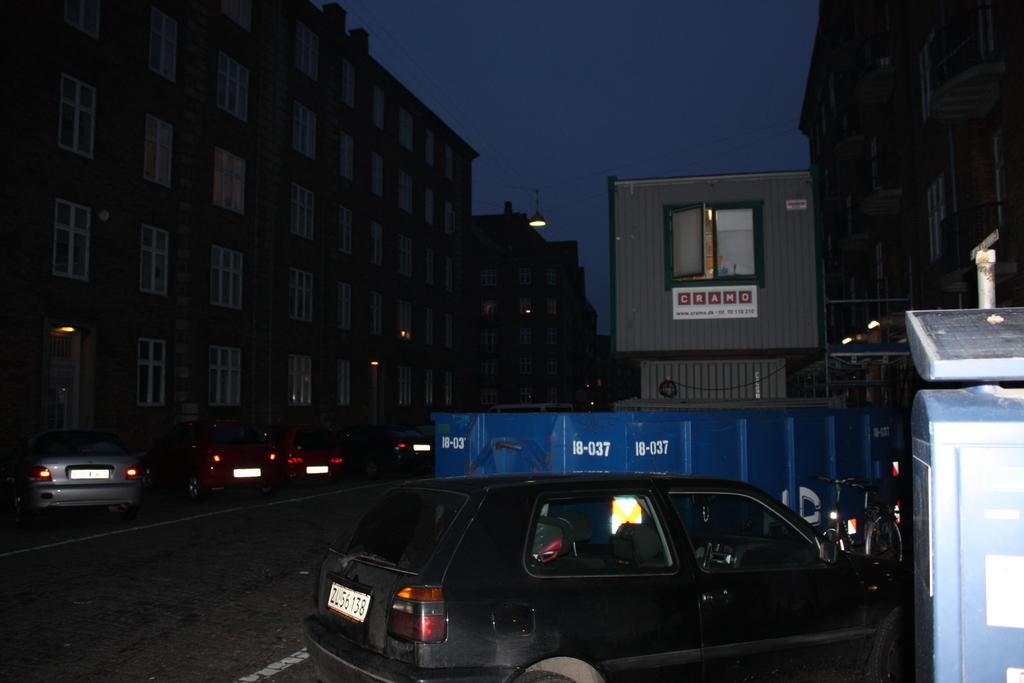What can be seen on the road in the image? There are cars parked on the road in the image. What can be seen in the distance in the image? There are buildings visible in the background of the image. How many boys are playing with a bat in the image? There are no boys or bats present in the image. 